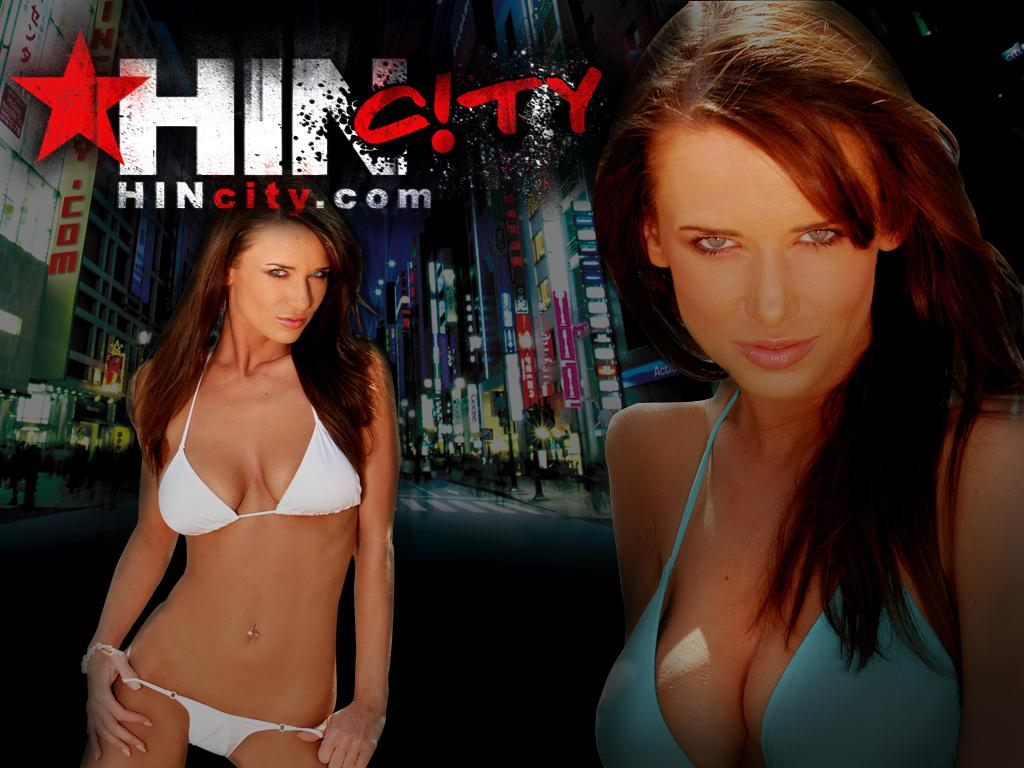What is present on the posters in the image? The posters contain images of buildings and girls. Can you describe the content of the posters in more detail? The posters have images of buildings and girls, which suggests they might be related to architecture or fashion. How many ducks are visible on the posters in the image? There are no ducks present on the posters in the image. What type of tooth is featured in the image? There is no tooth present in the image; it features posters with images of buildings and girls. 